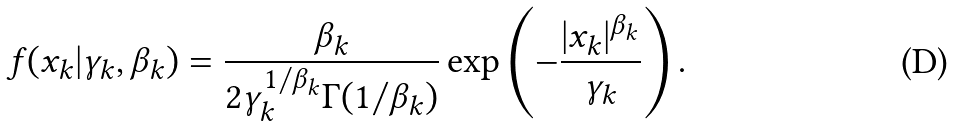<formula> <loc_0><loc_0><loc_500><loc_500>f ( x _ { k } | \gamma _ { k } , \beta _ { k } ) = \frac { \beta _ { k } } { 2 \gamma _ { k } ^ { 1 / \beta _ { k } } \Gamma ( 1 / \beta _ { k } ) } \exp \left ( - \frac { | x _ { k } | ^ { \beta _ { k } } } { \gamma _ { k } } \right ) .</formula> 